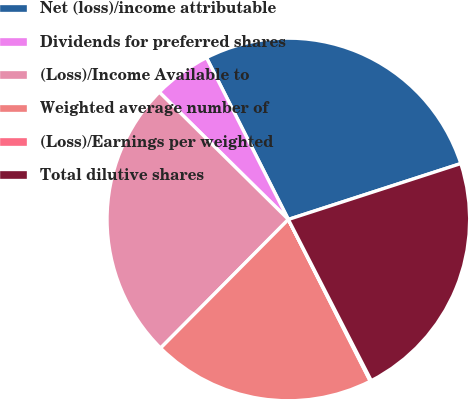Convert chart to OTSL. <chart><loc_0><loc_0><loc_500><loc_500><pie_chart><fcel>Net (loss)/income attributable<fcel>Dividends for preferred shares<fcel>(Loss)/Income Available to<fcel>Weighted average number of<fcel>(Loss)/Earnings per weighted<fcel>Total dilutive shares<nl><fcel>27.47%<fcel>5.15%<fcel>24.95%<fcel>19.91%<fcel>0.1%<fcel>22.43%<nl></chart> 